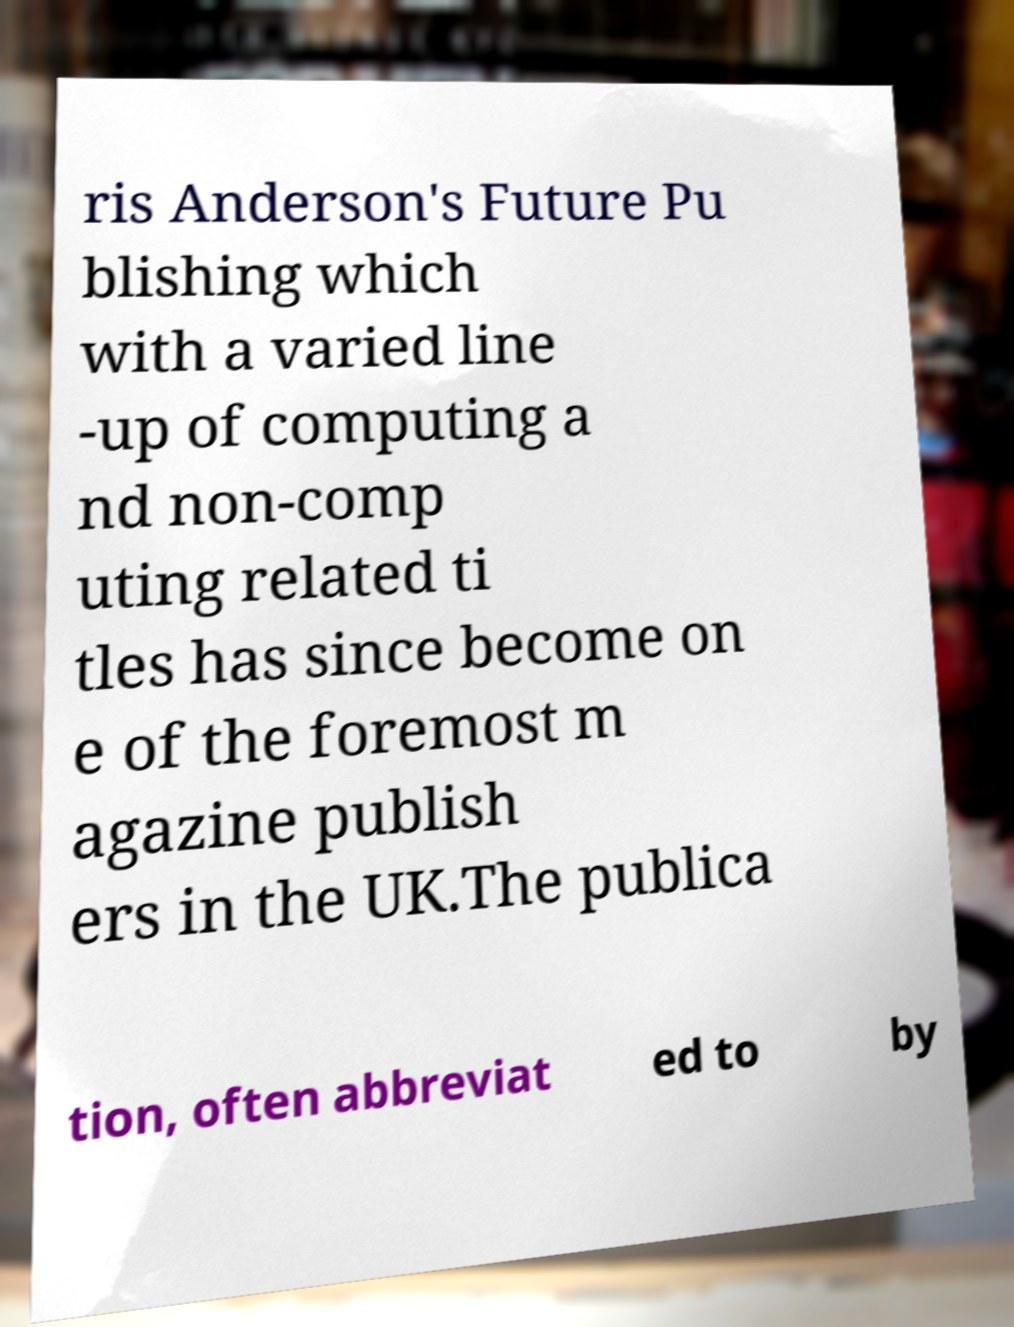Could you assist in decoding the text presented in this image and type it out clearly? ris Anderson's Future Pu blishing which with a varied line -up of computing a nd non-comp uting related ti tles has since become on e of the foremost m agazine publish ers in the UK.The publica tion, often abbreviat ed to by 